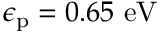Convert formula to latex. <formula><loc_0><loc_0><loc_500><loc_500>\epsilon _ { p } = 0 . 6 5 e V</formula> 